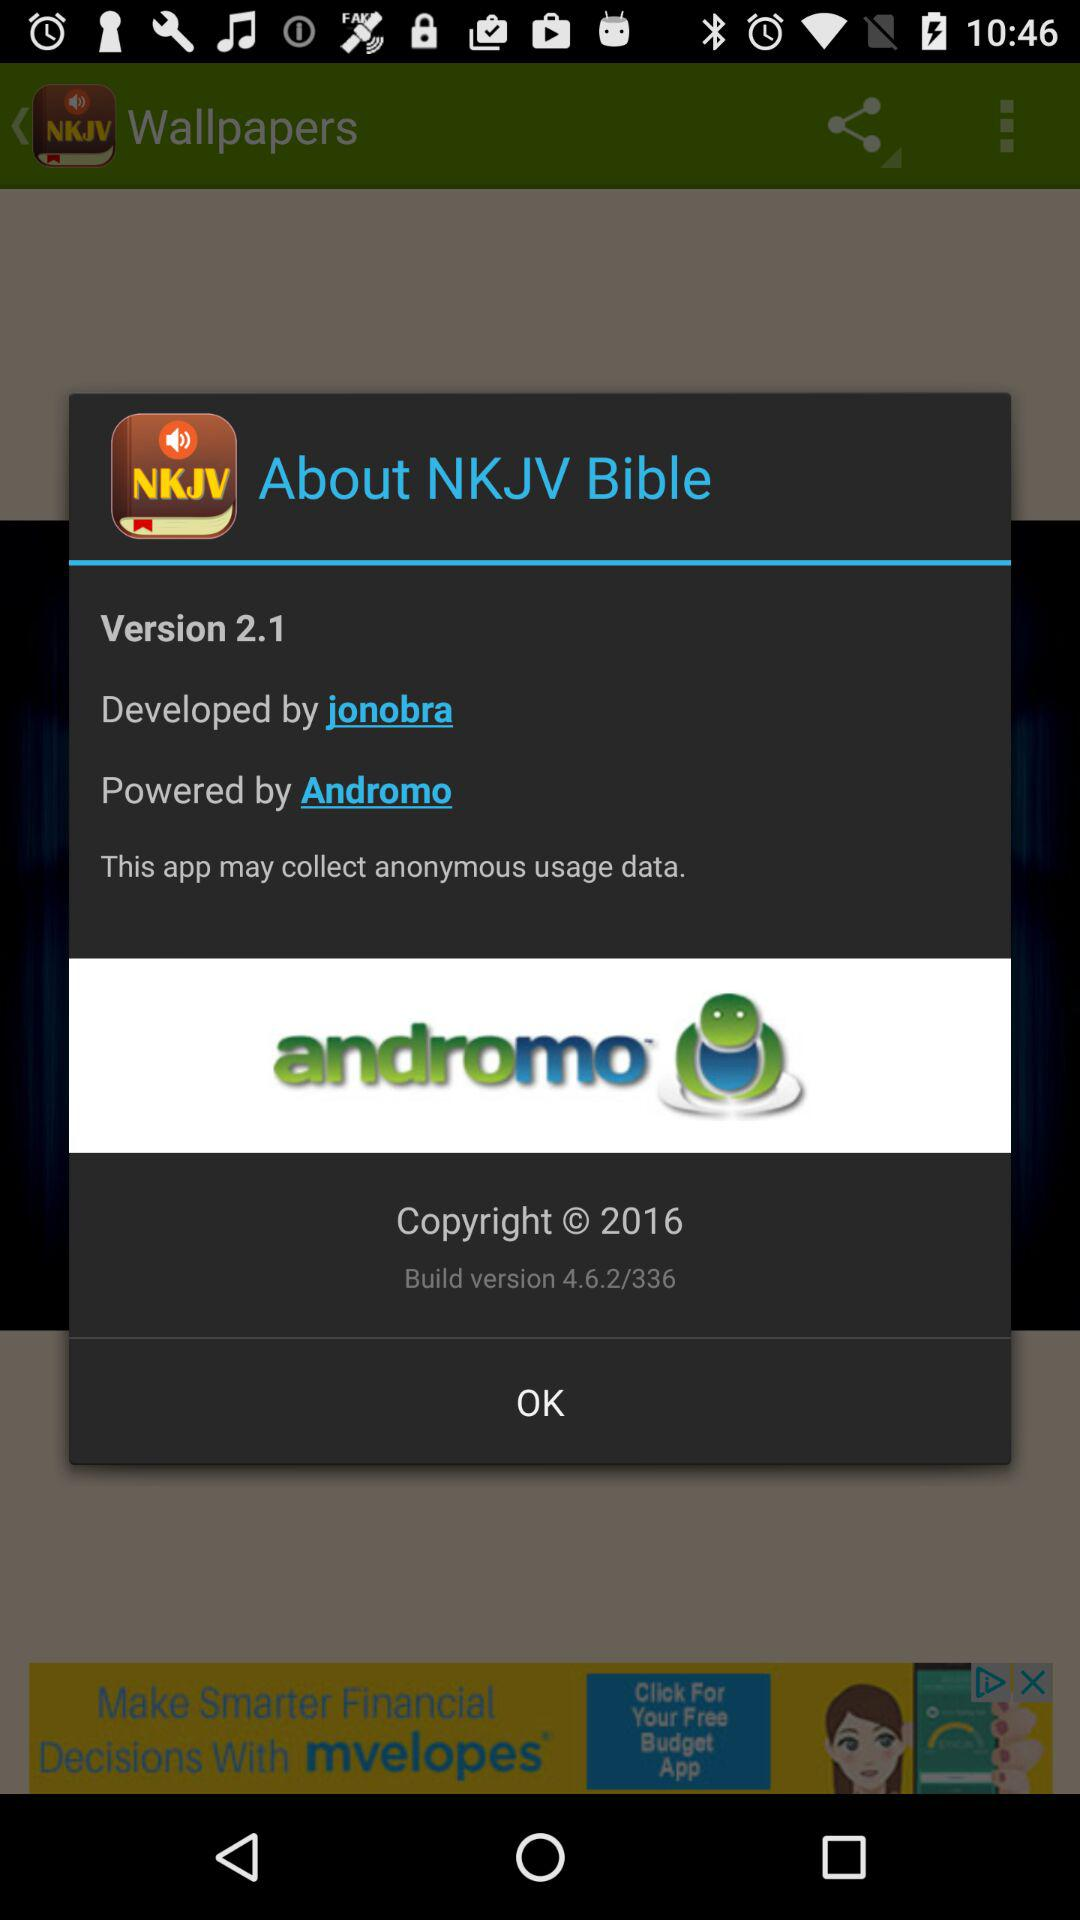What is the build version number? The build version number is 4.6.2/336. 